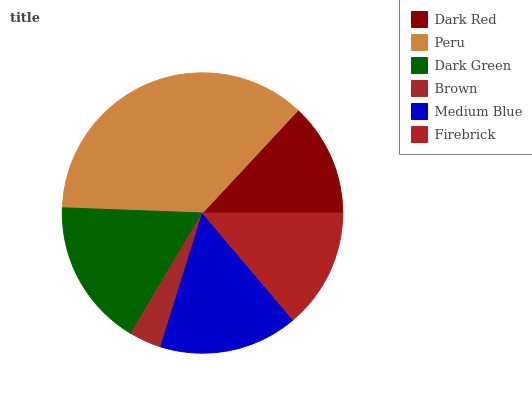Is Brown the minimum?
Answer yes or no. Yes. Is Peru the maximum?
Answer yes or no. Yes. Is Dark Green the minimum?
Answer yes or no. No. Is Dark Green the maximum?
Answer yes or no. No. Is Peru greater than Dark Green?
Answer yes or no. Yes. Is Dark Green less than Peru?
Answer yes or no. Yes. Is Dark Green greater than Peru?
Answer yes or no. No. Is Peru less than Dark Green?
Answer yes or no. No. Is Medium Blue the high median?
Answer yes or no. Yes. Is Firebrick the low median?
Answer yes or no. Yes. Is Peru the high median?
Answer yes or no. No. Is Dark Green the low median?
Answer yes or no. No. 